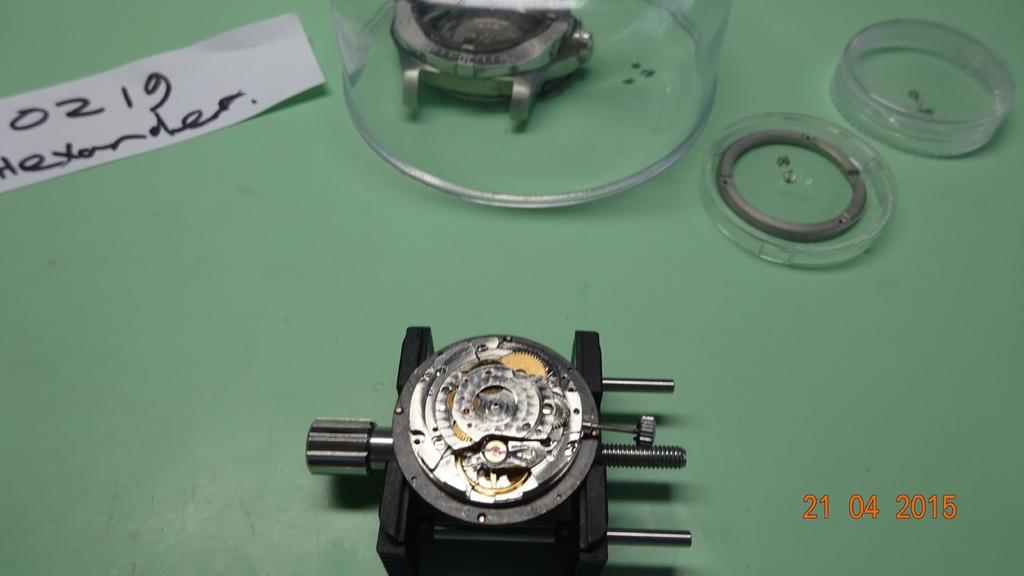<image>
Write a terse but informative summary of the picture. A dismantled watch movement is held in a vise and a white strip of paper above and to the left of it has 0219 Alexander written on it. 